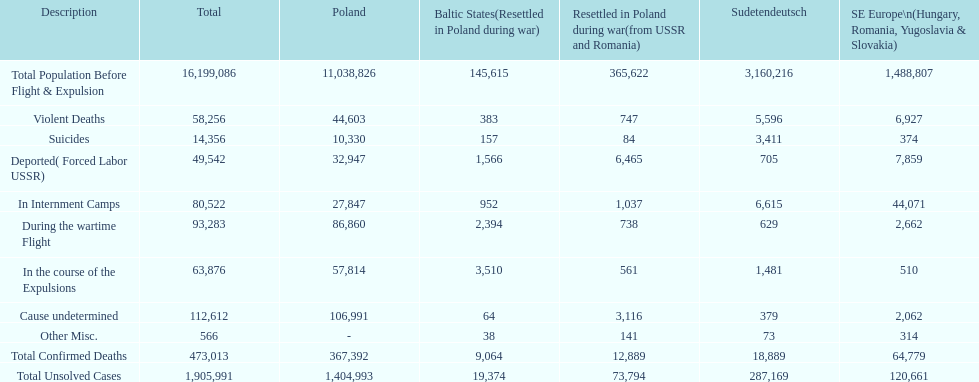How many causes were responsible for more than 50,000 confirmed deaths? 5. 